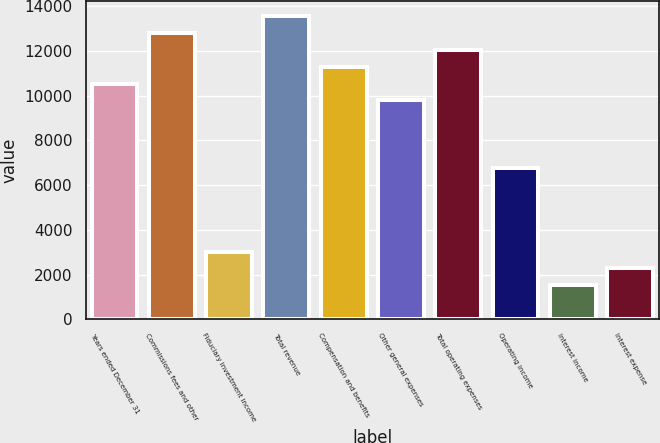Convert chart to OTSL. <chart><loc_0><loc_0><loc_500><loc_500><bar_chart><fcel>Years ended December 31<fcel>Commissions fees and other<fcel>Fiduciary investment income<fcel>Total revenue<fcel>Compensation and benefits<fcel>Other general expenses<fcel>Total operating expenses<fcel>Operating income<fcel>Interest income<fcel>Interest expense<nl><fcel>10532.8<fcel>12786.4<fcel>3020.8<fcel>13537.6<fcel>11284<fcel>9781.6<fcel>12035.2<fcel>6776.8<fcel>1518.4<fcel>2269.6<nl></chart> 